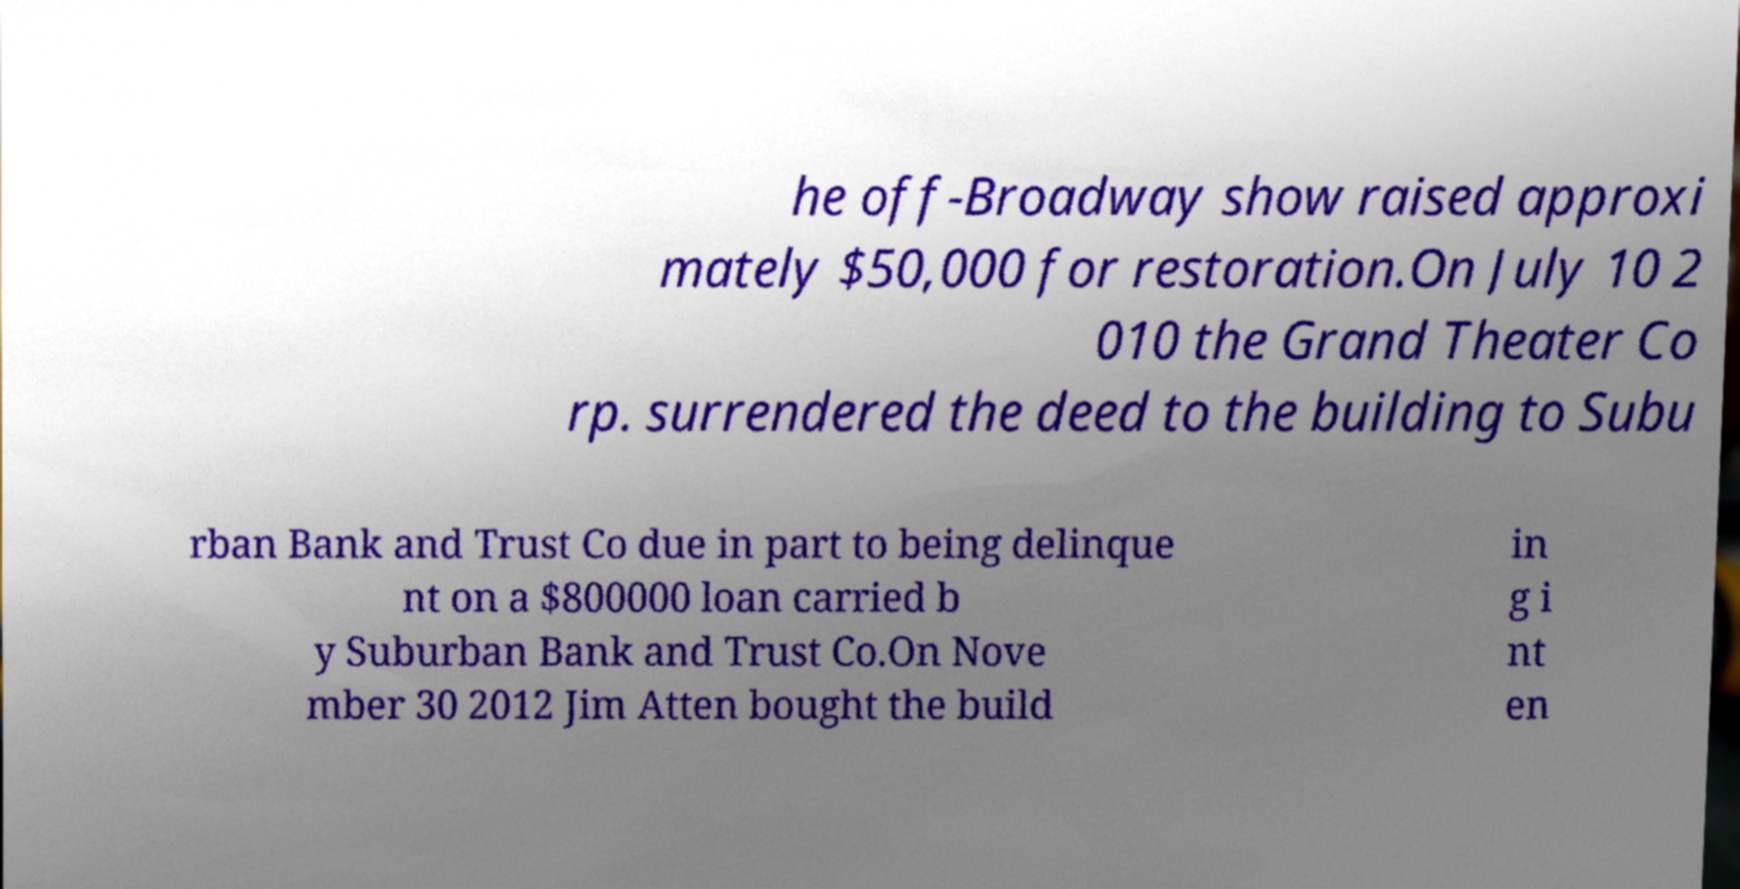Please identify and transcribe the text found in this image. he off-Broadway show raised approxi mately $50,000 for restoration.On July 10 2 010 the Grand Theater Co rp. surrendered the deed to the building to Subu rban Bank and Trust Co due in part to being delinque nt on a $800000 loan carried b y Suburban Bank and Trust Co.On Nove mber 30 2012 Jim Atten bought the build in g i nt en 